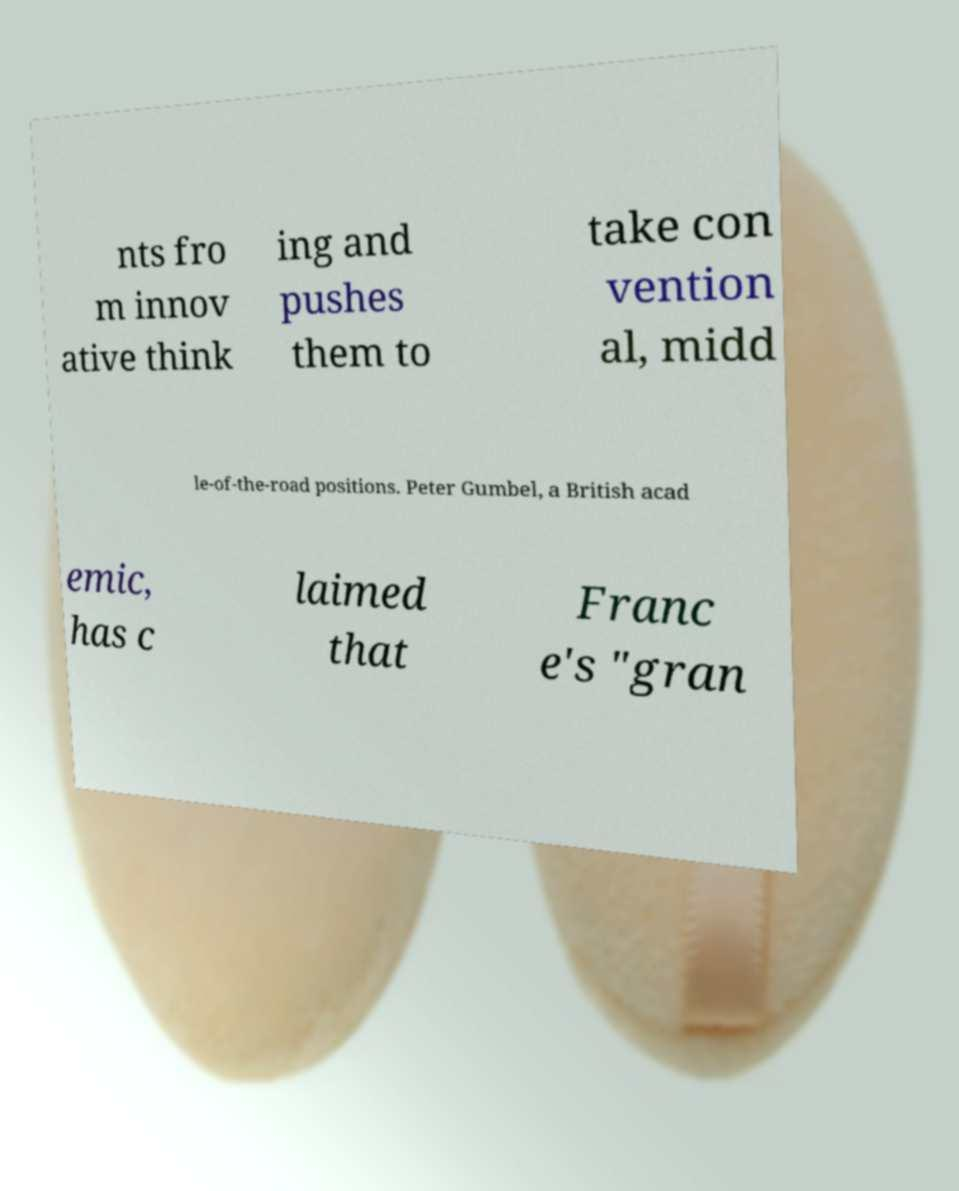I need the written content from this picture converted into text. Can you do that? nts fro m innov ative think ing and pushes them to take con vention al, midd le-of-the-road positions. Peter Gumbel, a British acad emic, has c laimed that Franc e's "gran 